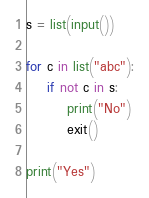<code> <loc_0><loc_0><loc_500><loc_500><_Python_>s = list(input())

for c in list("abc"):
	if not c in s:
		print("No")
		exit()

print("Yes")
</code> 